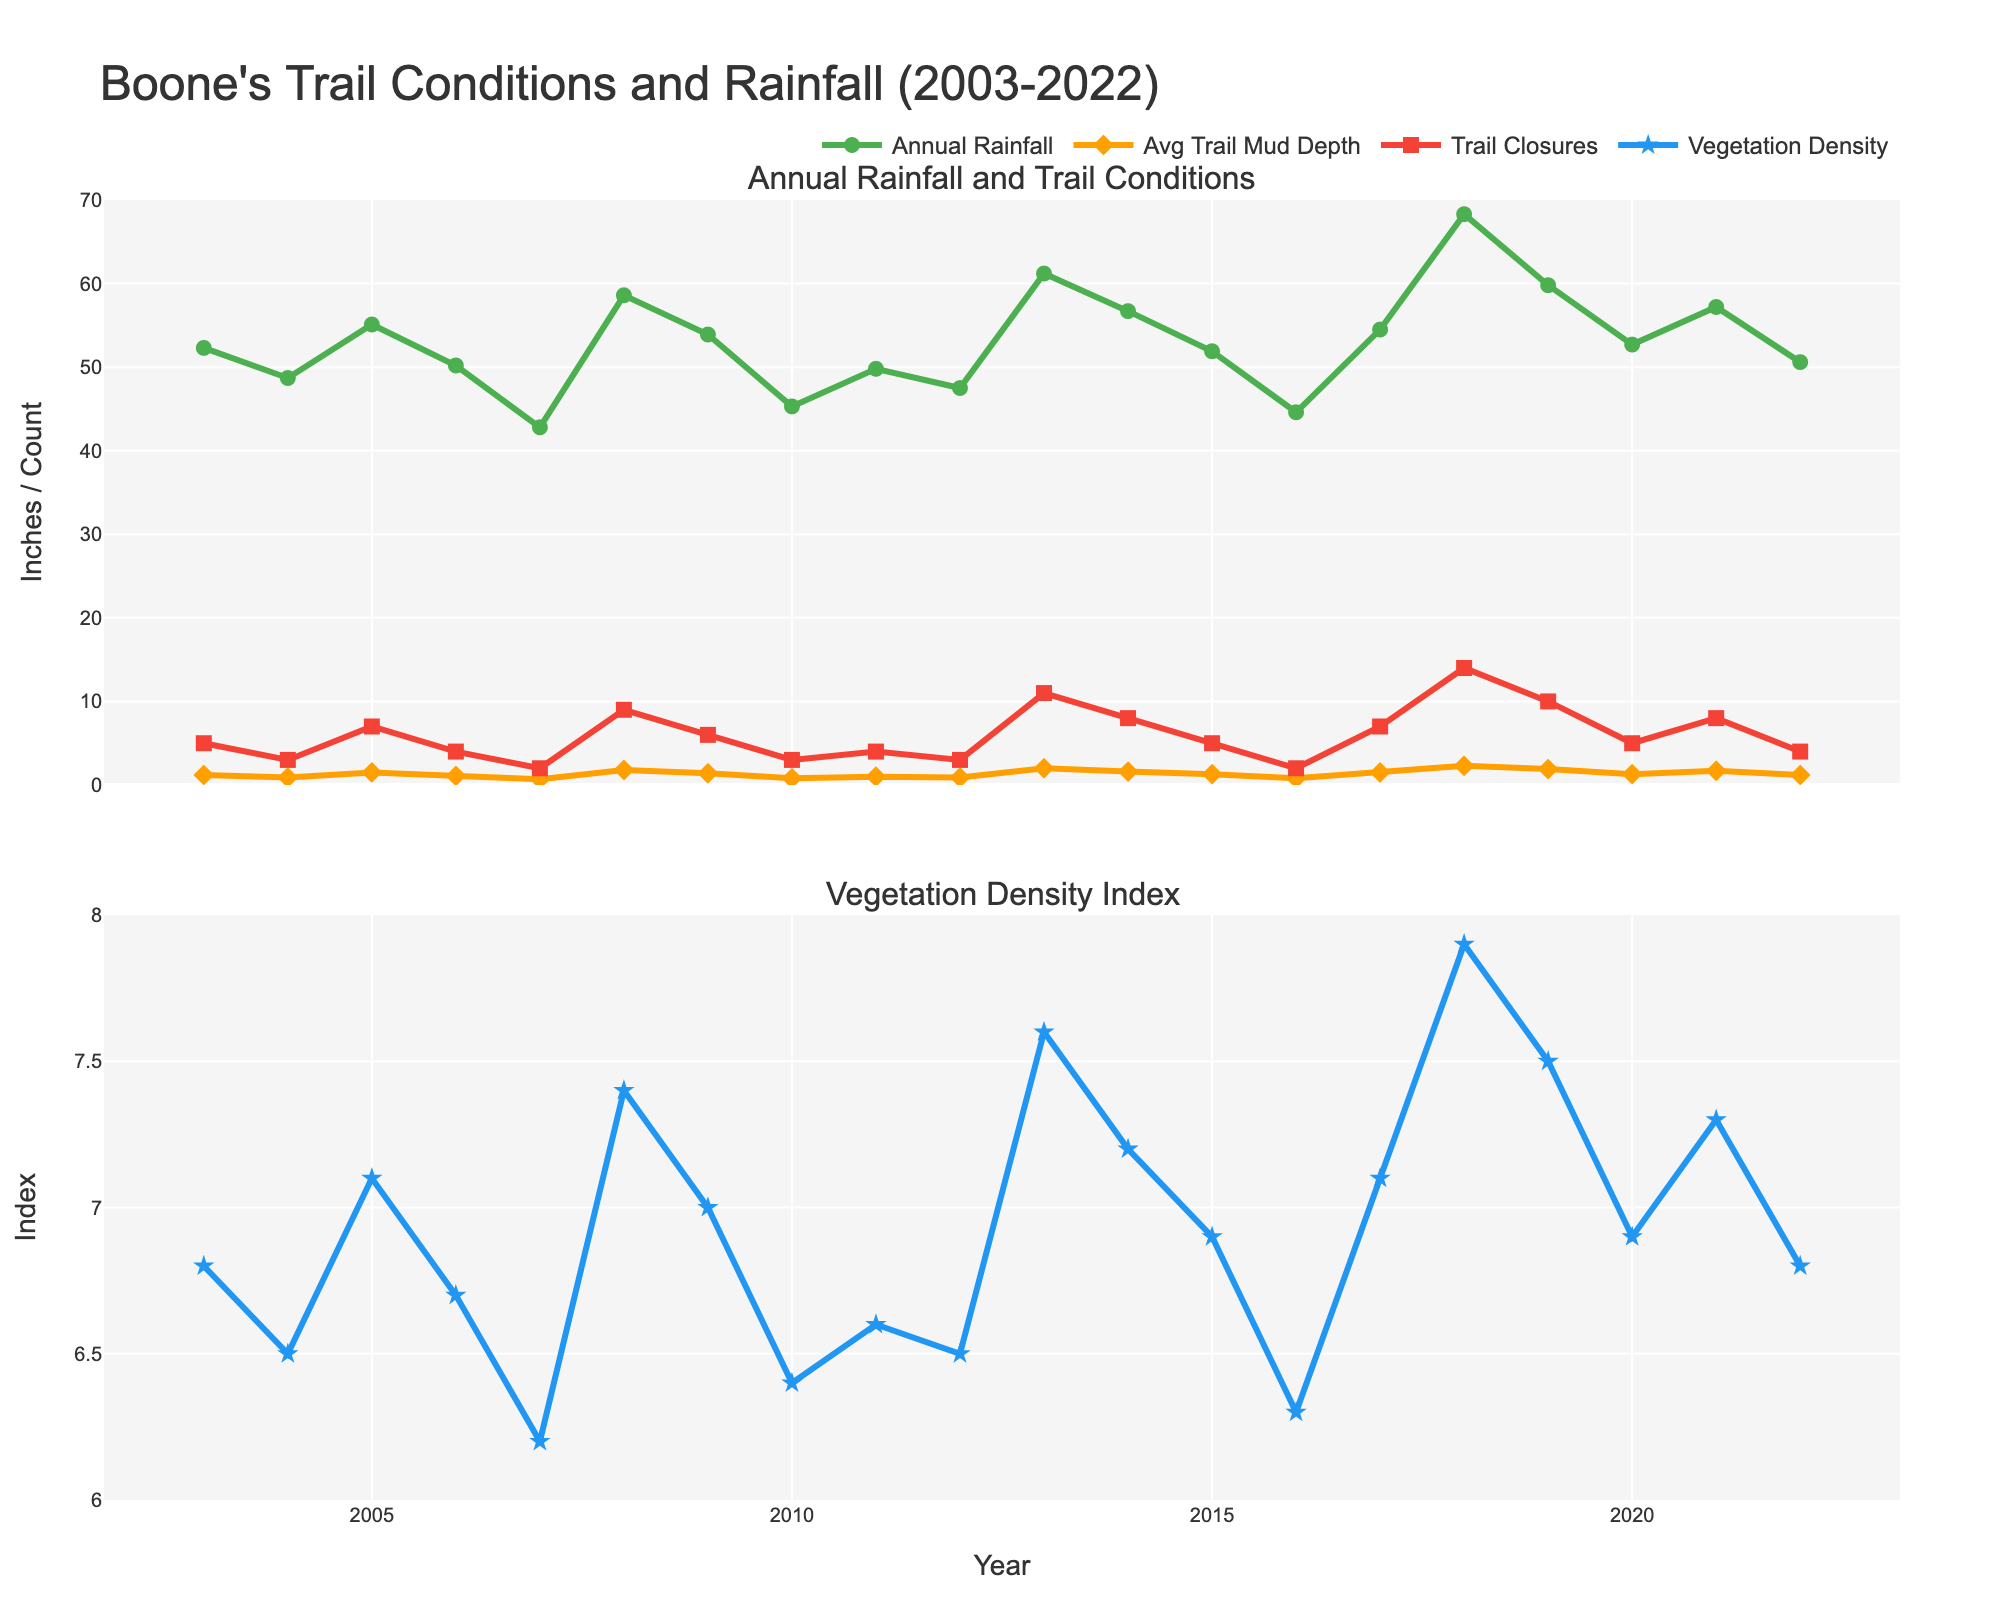What is the average Annual Rainfall over the 20-year period? First, sum all the Annual Rainfall values and then divide by the number of years. (52.3 + 48.7 + 55.1 + 50.2 + 42.8 + 58.6 + 53.9 + 45.3 + 49.8 + 47.5 + 61.2 + 56.7 + 51.9 + 44.6 + 54.5 + 68.3 + 59.8 + 52.7 + 57.2 + 50.6) / 20 = 53.11 inches
Answer: 53.11 inches How does the trend of Average Trail Mud Depth relate to Annual Rainfall? Observe that years with higher Annual Rainfall generally correspond to higher Average Trail Mud Depth, indicating that more rainfall leads to muddier trails. For example, in 2018, both Annual Rainfall and Mud Depth peak.
Answer: Positive correlation In which year was the Vegetation Density Index the highest? Look for the peak value in the Vegetation Density Index plot. The highest value is at 2018 with an index of 7.9.
Answer: 2018 Which year had the most Number of Trail Closures? Find the tallest point in the Trail Closures line in the first subplot, which is in 2018 with the most closures at 14.
Answer: 2018 Compare Annual Rainfall in 2007 and 2018. Which one is higher and by how much? 2018 had 68.3 inches of rainfall whereas 2007 had 42.8 inches. 68.3 - 42.8 = 25.5 inches more in 2018.
Answer: 2018 by 25.5 inches What was the trend in Vegetation Density Index from 2003 to 2022? Examine the overall pattern in the second subplot. The Vegetation Density Index shows an overall increasing trend from about 6.8 in 2003 to around 6.8 in 2022 with fluctuations and a peak in 2018.
Answer: Increasing trend Which year had the highest Average Trail Mud Depth and what was the value? Look for the highest point in the Average Trail Mud Depth line in the first subplot. The highest value is in 2018, with a depth of 2.3 inches.
Answer: 2018, 2.3 inches Is there any year where the Number of Trail Closures equals the sum of Average Trail Mud Depth and Vegetation Density Index for that year? Compare each year's Number of Trail Closures to the sum of that year's Average Trail Mud Depth and Vegetation Density Index. For example, in 2014: 1.6 + 7.2 = 8.8 but closures are 8, none match exactly.
Answer: No What is the range of Annual Rainfall observed over the 20-year period? Identify the minimum and the maximum Annual Rainfall values from the plot. Minimum is 42.8 inches (2007) and maximum is 68.3 inches (2018). Range is 68.3 - 42.8 = 25.5 inches.
Answer: 25.5 inches How did trail conditions change in terms of Number of Trail Closures post-2010 compared to pre-2010? Calculate the average Number of Trail Closures for 2003-2010 and 2011-2022. Pre-2010 sum/8 = (5+3+7+4+2+9+6+3)/8 = 4.875. Post-2010 sum/12 = (4+3+11+8+5+2+7+14+10+5+8+4)/12 = 6.25. Number of closures increased in the post-2010 period.
Answer: Increased 